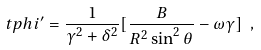<formula> <loc_0><loc_0><loc_500><loc_500>\ t p h i ^ { \prime } = \frac { 1 } { \gamma ^ { 2 } + \delta ^ { 2 } } [ \frac { B } { R ^ { 2 } \sin ^ { 2 } \theta } - \omega \gamma ] \ ,</formula> 